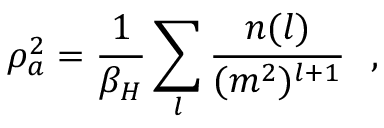Convert formula to latex. <formula><loc_0><loc_0><loc_500><loc_500>\rho _ { a } ^ { 2 } = { \frac { 1 } { \beta _ { H } } } \sum _ { l } { \frac { n ( l ) } { ( m ^ { 2 } ) ^ { l + 1 } } } ,</formula> 